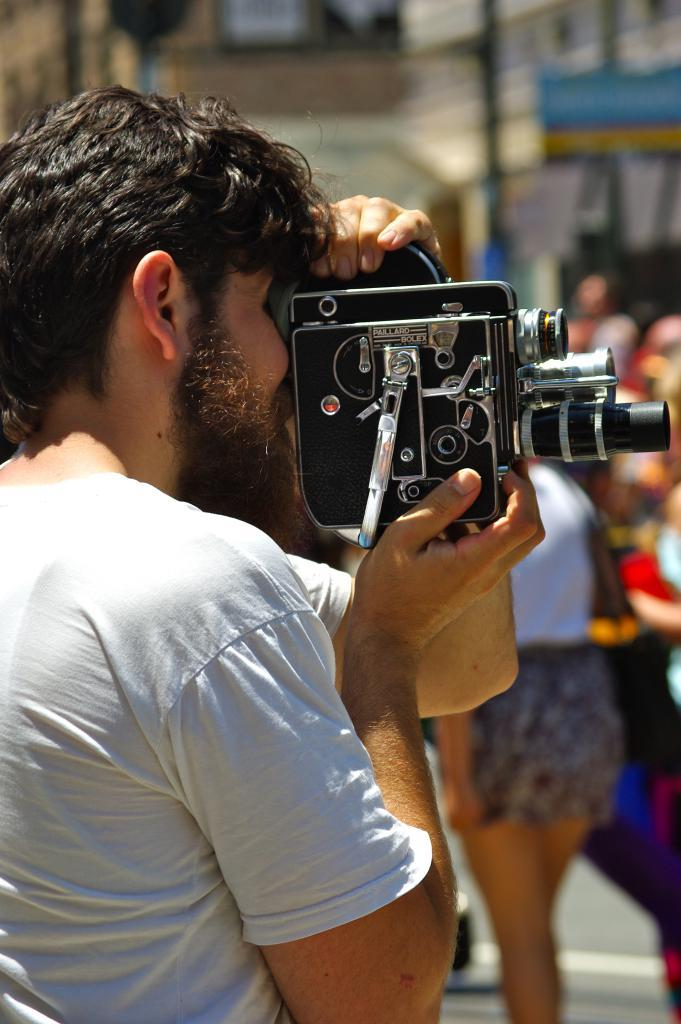What is the main subject of the image? The main subject of the image is a bearded man. What is the man doing in the image? The man is holding a camera with both hands and clicking an image. How many people are visible in the image? There are many people in the image. What can be seen in the background of the image? There are buildings in the background of the image. Where was the image taken? The image was taken on a road. Can you see any pigs swimming in the image? There are no pigs or swimming activities depicted in the image. 